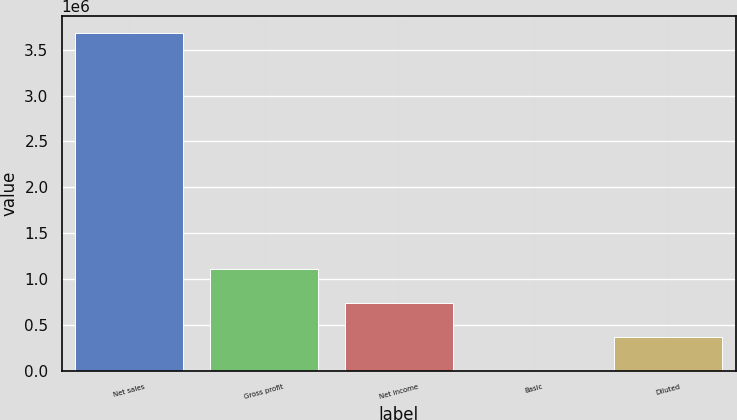Convert chart. <chart><loc_0><loc_0><loc_500><loc_500><bar_chart><fcel>Net sales<fcel>Gross profit<fcel>Net income<fcel>Basic<fcel>Diluted<nl><fcel>3.68179e+06<fcel>1.10454e+06<fcel>736359<fcel>1.07<fcel>368180<nl></chart> 